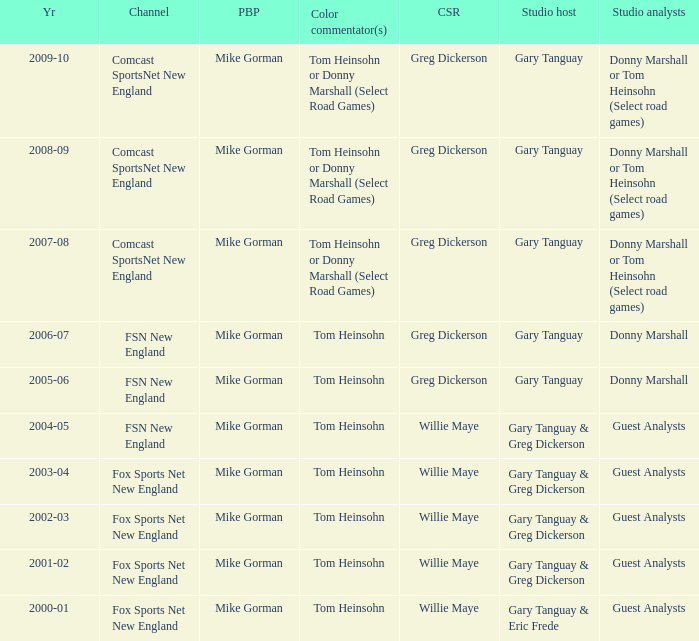WHich Play-by-play has a Studio host of gary tanguay, and a Studio analysts of donny marshall? Mike Gorman, Mike Gorman. Can you parse all the data within this table? {'header': ['Yr', 'Channel', 'PBP', 'Color commentator(s)', 'CSR', 'Studio host', 'Studio analysts'], 'rows': [['2009-10', 'Comcast SportsNet New England', 'Mike Gorman', 'Tom Heinsohn or Donny Marshall (Select Road Games)', 'Greg Dickerson', 'Gary Tanguay', 'Donny Marshall or Tom Heinsohn (Select road games)'], ['2008-09', 'Comcast SportsNet New England', 'Mike Gorman', 'Tom Heinsohn or Donny Marshall (Select Road Games)', 'Greg Dickerson', 'Gary Tanguay', 'Donny Marshall or Tom Heinsohn (Select road games)'], ['2007-08', 'Comcast SportsNet New England', 'Mike Gorman', 'Tom Heinsohn or Donny Marshall (Select Road Games)', 'Greg Dickerson', 'Gary Tanguay', 'Donny Marshall or Tom Heinsohn (Select road games)'], ['2006-07', 'FSN New England', 'Mike Gorman', 'Tom Heinsohn', 'Greg Dickerson', 'Gary Tanguay', 'Donny Marshall'], ['2005-06', 'FSN New England', 'Mike Gorman', 'Tom Heinsohn', 'Greg Dickerson', 'Gary Tanguay', 'Donny Marshall'], ['2004-05', 'FSN New England', 'Mike Gorman', 'Tom Heinsohn', 'Willie Maye', 'Gary Tanguay & Greg Dickerson', 'Guest Analysts'], ['2003-04', 'Fox Sports Net New England', 'Mike Gorman', 'Tom Heinsohn', 'Willie Maye', 'Gary Tanguay & Greg Dickerson', 'Guest Analysts'], ['2002-03', 'Fox Sports Net New England', 'Mike Gorman', 'Tom Heinsohn', 'Willie Maye', 'Gary Tanguay & Greg Dickerson', 'Guest Analysts'], ['2001-02', 'Fox Sports Net New England', 'Mike Gorman', 'Tom Heinsohn', 'Willie Maye', 'Gary Tanguay & Greg Dickerson', 'Guest Analysts'], ['2000-01', 'Fox Sports Net New England', 'Mike Gorman', 'Tom Heinsohn', 'Willie Maye', 'Gary Tanguay & Eric Frede', 'Guest Analysts']]} 